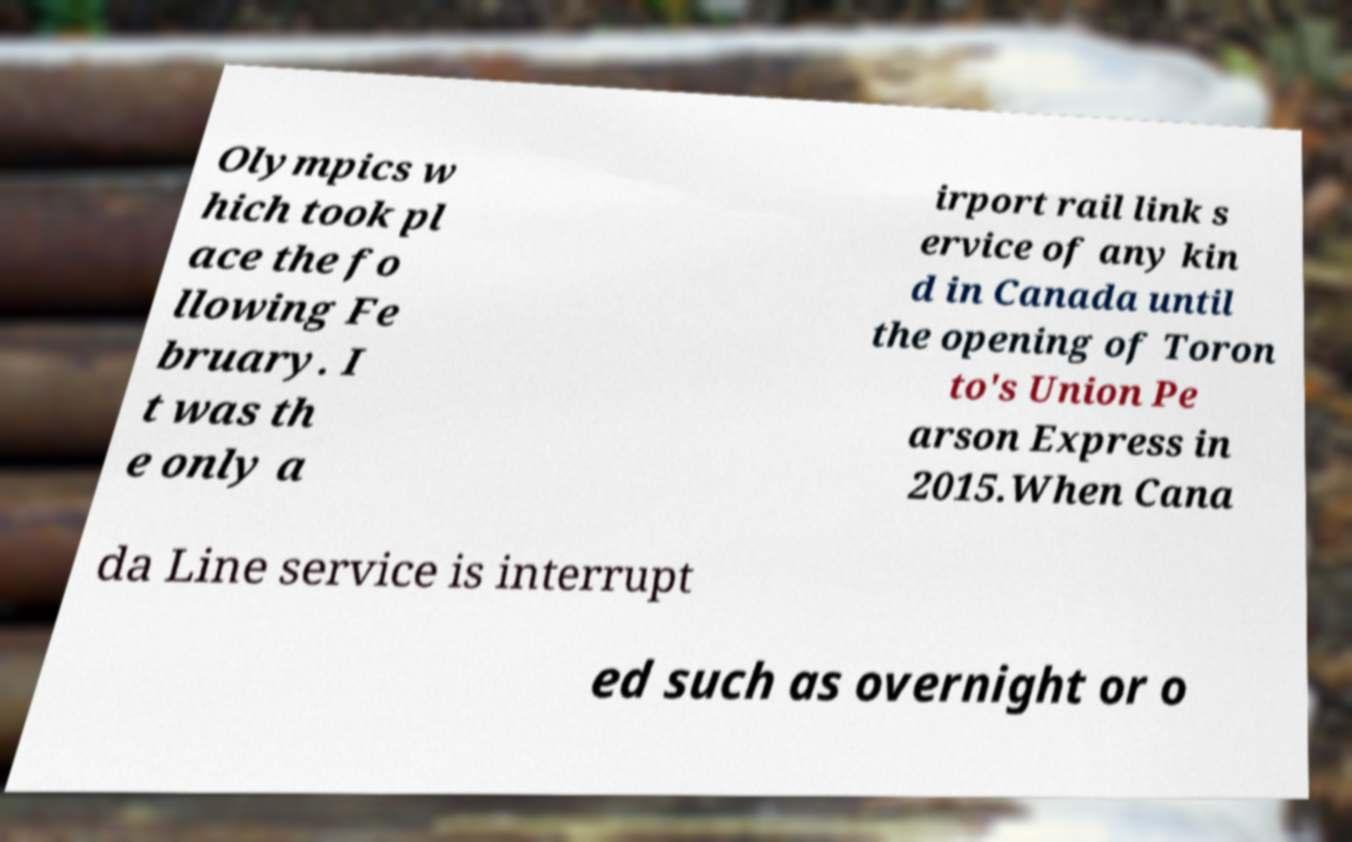Please identify and transcribe the text found in this image. Olympics w hich took pl ace the fo llowing Fe bruary. I t was th e only a irport rail link s ervice of any kin d in Canada until the opening of Toron to's Union Pe arson Express in 2015.When Cana da Line service is interrupt ed such as overnight or o 